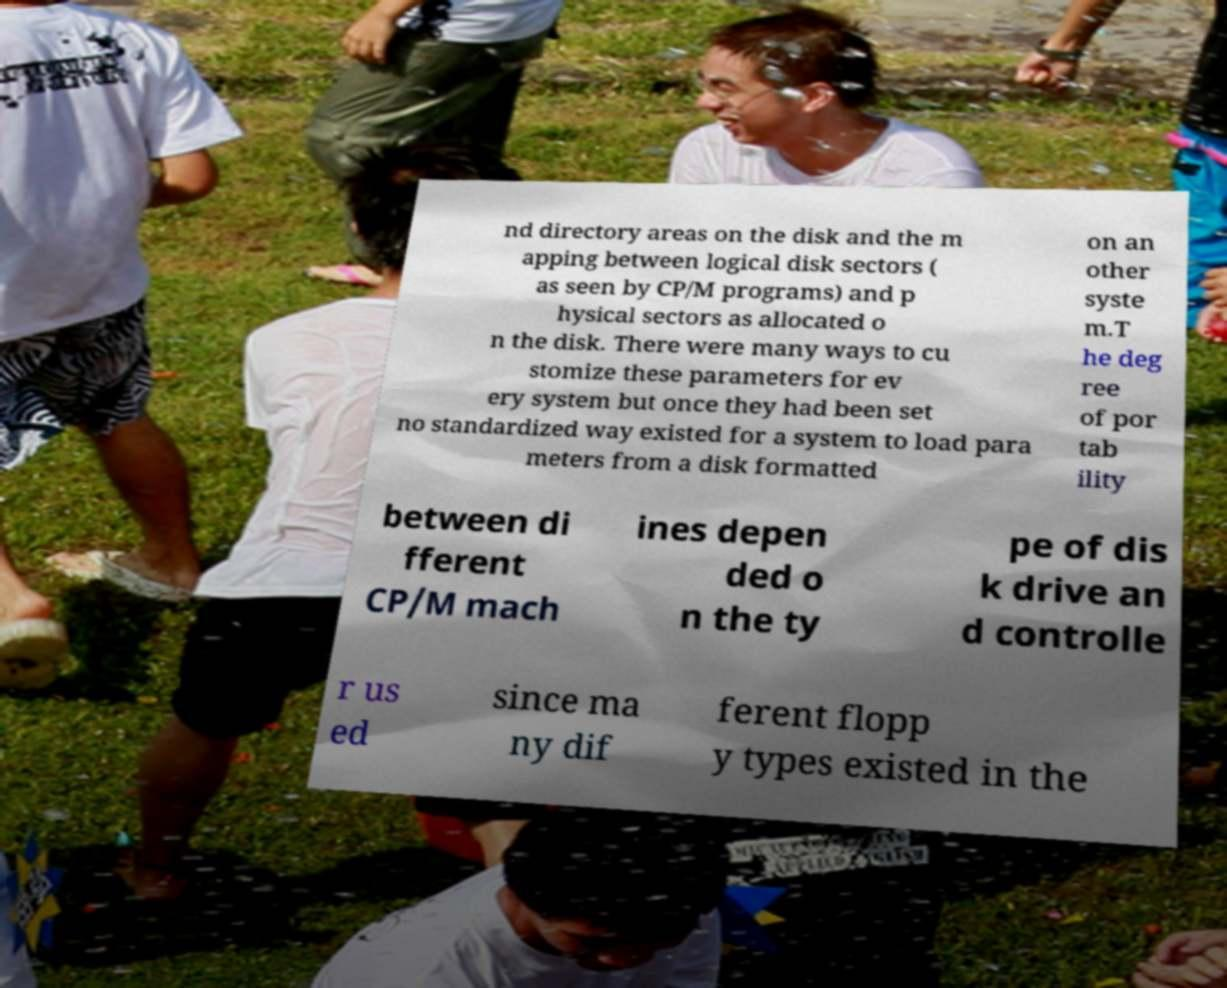There's text embedded in this image that I need extracted. Can you transcribe it verbatim? nd directory areas on the disk and the m apping between logical disk sectors ( as seen by CP/M programs) and p hysical sectors as allocated o n the disk. There were many ways to cu stomize these parameters for ev ery system but once they had been set no standardized way existed for a system to load para meters from a disk formatted on an other syste m.T he deg ree of por tab ility between di fferent CP/M mach ines depen ded o n the ty pe of dis k drive an d controlle r us ed since ma ny dif ferent flopp y types existed in the 